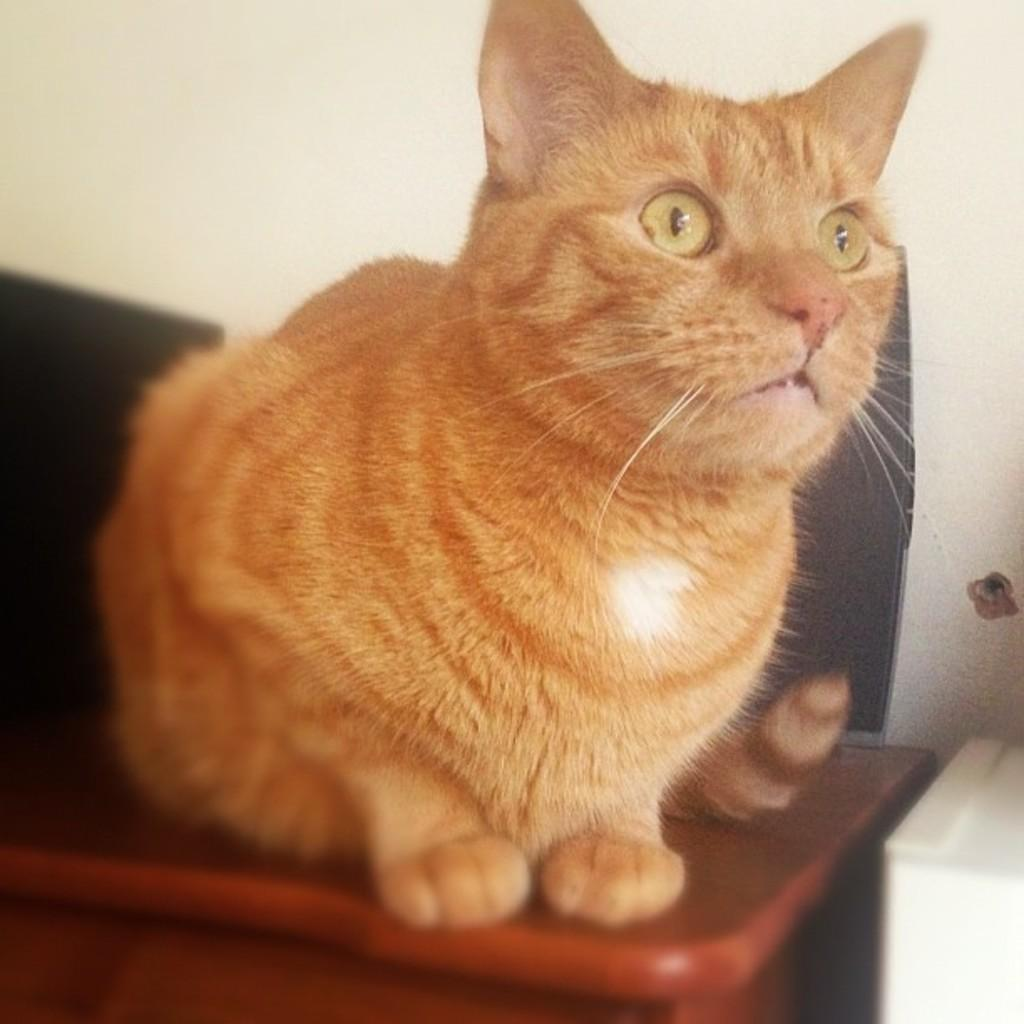What animal is on the table in the image? There is a cat on the table in the image. What color are the objects behind the cat? The objects behind the cat are black. What can be seen beside the table? There is an object beside the table. What is visible in the background of the image? There is a wall in the background of the image. What type of board is the cat using to play in the image? There is no board present in the image, and the cat is not playing. 